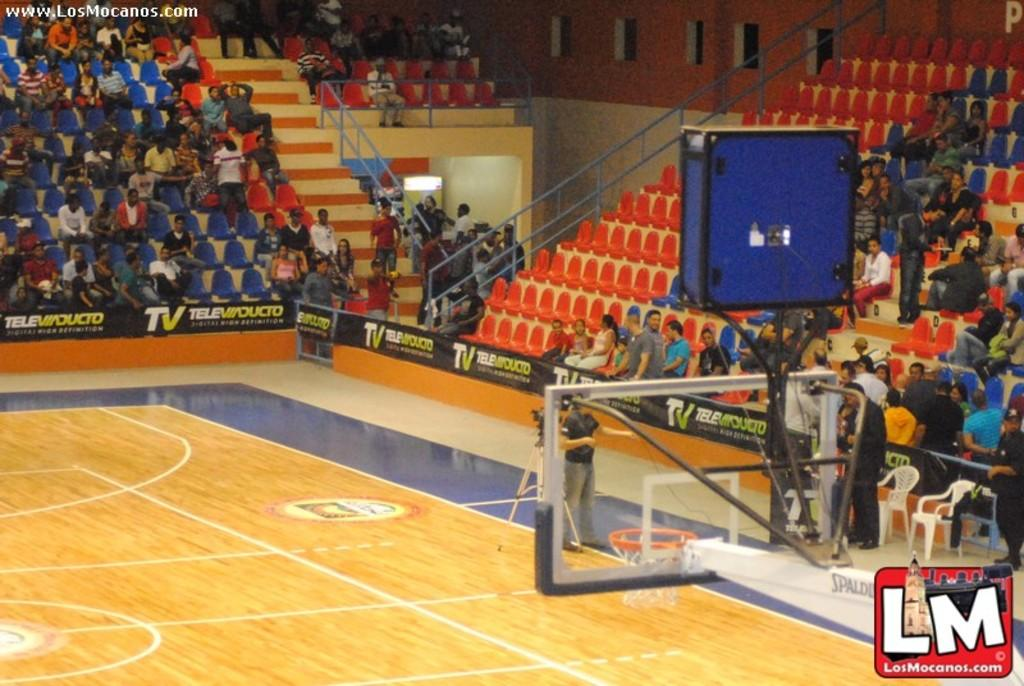<image>
Give a short and clear explanation of the subsequent image. A basketball court with people watch and a LM logo in the corner. 